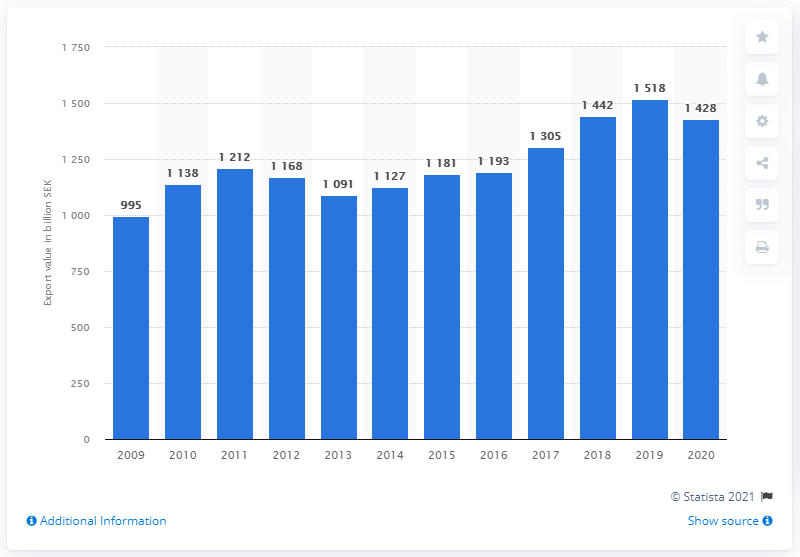Mention a couple of crucial points in this snapshot. In 2020, the total value of Swedish exports of goods worth a total of 142.8 billion Swedish kronor. 